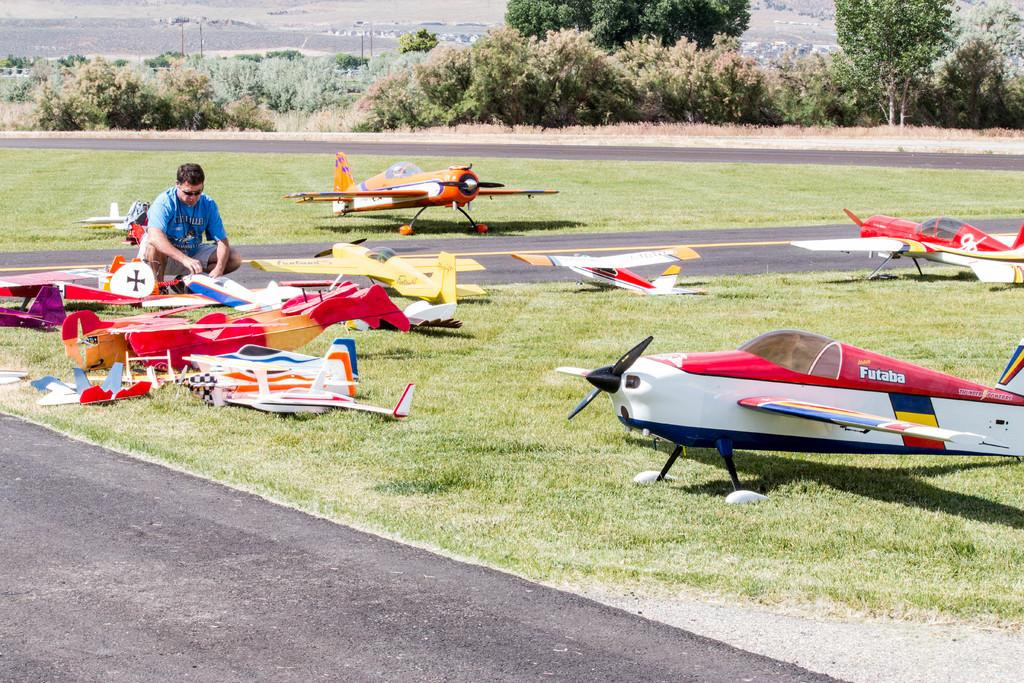<image>
Present a compact description of the photo's key features. The Futaba plane is red, white and blue and is one of the largest here 